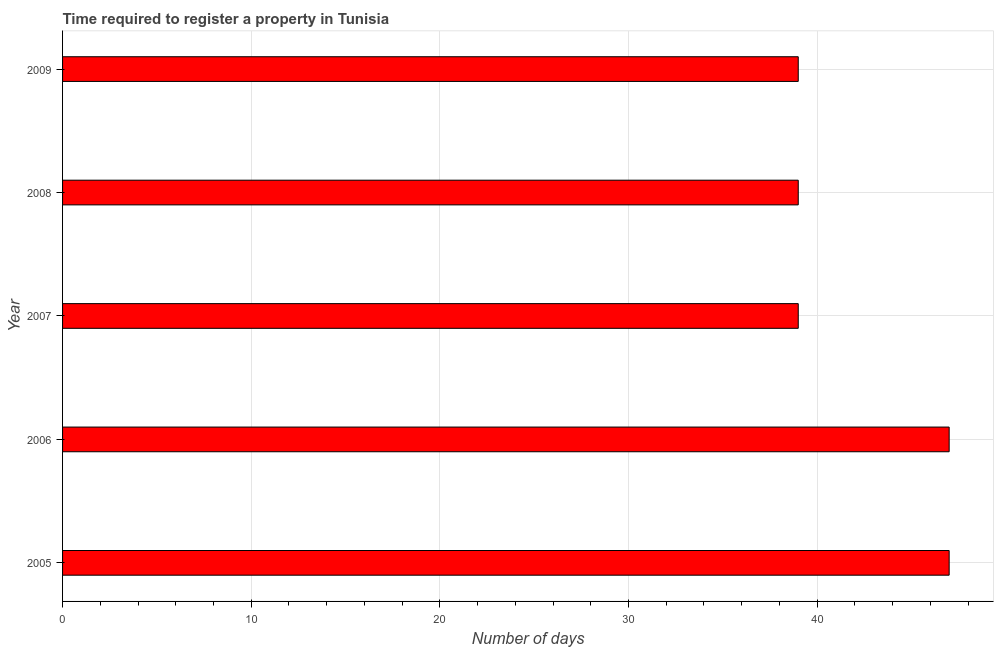What is the title of the graph?
Give a very brief answer. Time required to register a property in Tunisia. What is the label or title of the X-axis?
Provide a succinct answer. Number of days. What is the label or title of the Y-axis?
Your answer should be very brief. Year. What is the number of days required to register property in 2006?
Provide a short and direct response. 47. In which year was the number of days required to register property maximum?
Provide a short and direct response. 2005. What is the sum of the number of days required to register property?
Offer a very short reply. 211. What is the ratio of the number of days required to register property in 2006 to that in 2007?
Ensure brevity in your answer.  1.21. Is the difference between the number of days required to register property in 2006 and 2007 greater than the difference between any two years?
Your response must be concise. Yes. Is the sum of the number of days required to register property in 2005 and 2008 greater than the maximum number of days required to register property across all years?
Your response must be concise. Yes. In how many years, is the number of days required to register property greater than the average number of days required to register property taken over all years?
Make the answer very short. 2. How many bars are there?
Keep it short and to the point. 5. Are all the bars in the graph horizontal?
Ensure brevity in your answer.  Yes. What is the difference between two consecutive major ticks on the X-axis?
Provide a succinct answer. 10. Are the values on the major ticks of X-axis written in scientific E-notation?
Make the answer very short. No. What is the Number of days of 2006?
Offer a very short reply. 47. What is the Number of days of 2007?
Provide a short and direct response. 39. What is the Number of days in 2009?
Offer a terse response. 39. What is the difference between the Number of days in 2005 and 2006?
Provide a succinct answer. 0. What is the difference between the Number of days in 2005 and 2008?
Keep it short and to the point. 8. What is the difference between the Number of days in 2006 and 2007?
Your answer should be very brief. 8. What is the difference between the Number of days in 2006 and 2009?
Your response must be concise. 8. What is the difference between the Number of days in 2007 and 2009?
Offer a very short reply. 0. What is the ratio of the Number of days in 2005 to that in 2006?
Your answer should be compact. 1. What is the ratio of the Number of days in 2005 to that in 2007?
Offer a very short reply. 1.21. What is the ratio of the Number of days in 2005 to that in 2008?
Your answer should be compact. 1.21. What is the ratio of the Number of days in 2005 to that in 2009?
Your answer should be very brief. 1.21. What is the ratio of the Number of days in 2006 to that in 2007?
Provide a short and direct response. 1.21. What is the ratio of the Number of days in 2006 to that in 2008?
Offer a terse response. 1.21. What is the ratio of the Number of days in 2006 to that in 2009?
Ensure brevity in your answer.  1.21. What is the ratio of the Number of days in 2007 to that in 2009?
Make the answer very short. 1. What is the ratio of the Number of days in 2008 to that in 2009?
Your response must be concise. 1. 